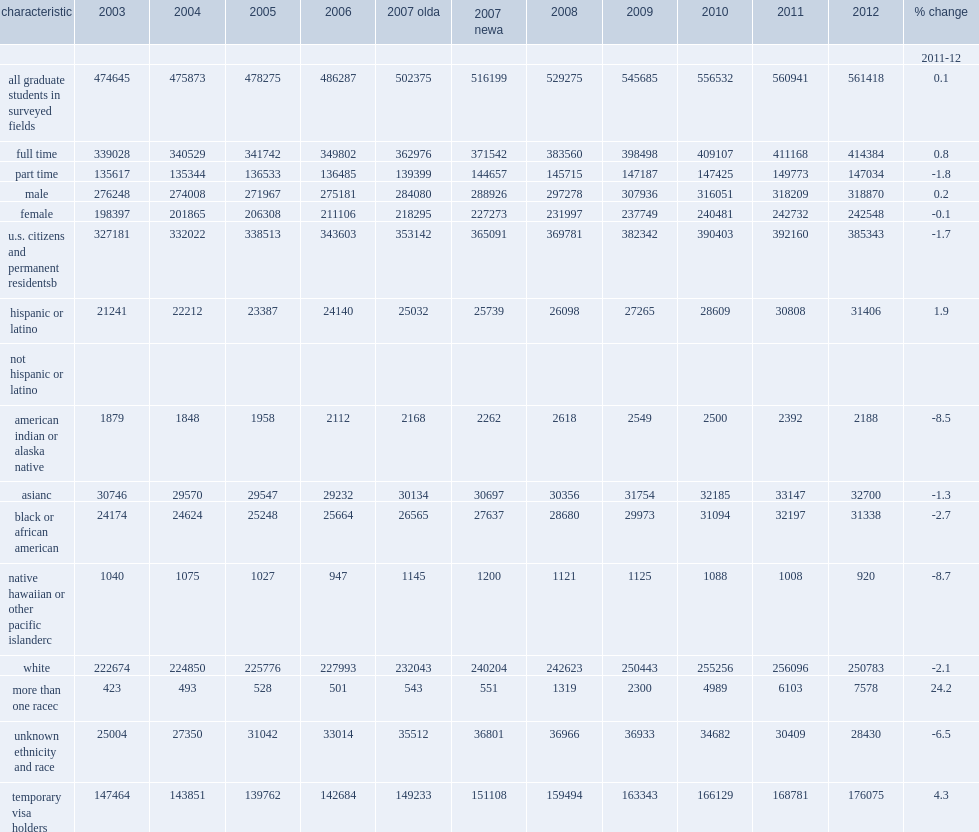What was the number of u.s. citizens and permanent residents enrolled in science and engineering (s&e) graduate programs declined to in 2012? 385343.0. How many percent of dropping from 2011 in enrollment of foreign s&e graduate students on temporary visas? 1.7. How many percent of increase in enrollment of foreign s&e graduate students on temporary visas? 4.3. An increase in enrollment of foreign s&e graduate students on temporary visas, how many students did it rise to? 176075.0. How many percent did enrollment of part-time s&e graduate students decline by? 1.8. How many students did enrollment of part-time s&e graduate students decline to? 147034.0. How many percent of full-time enrollment grew by in 2012? 0.8. How many students did full-time enrollment grow to in 2012? 414384.0. How many percent did full-time students make up of the s&e graduate student population? 0.738102. How many percent did women make up of the s&e graduate enrollment in 2012? 0.432027. Would you be able to parse every entry in this table? {'header': ['characteristic', '2003', '2004', '2005', '2006', '2007 olda', '2007 newa', '2008', '2009', '2010', '2011', '2012', '% change'], 'rows': [['', '', '', '', '', '', '', '', '', '', '', '', '2011-12'], ['all graduate students in surveyed fields', '474645', '475873', '478275', '486287', '502375', '516199', '529275', '545685', '556532', '560941', '561418', '0.1'], ['full time', '339028', '340529', '341742', '349802', '362976', '371542', '383560', '398498', '409107', '411168', '414384', '0.8'], ['part time', '135617', '135344', '136533', '136485', '139399', '144657', '145715', '147187', '147425', '149773', '147034', '-1.8'], ['male', '276248', '274008', '271967', '275181', '284080', '288926', '297278', '307936', '316051', '318209', '318870', '0.2'], ['female', '198397', '201865', '206308', '211106', '218295', '227273', '231997', '237749', '240481', '242732', '242548', '-0.1'], ['u.s. citizens and permanent residentsb', '327181', '332022', '338513', '343603', '353142', '365091', '369781', '382342', '390403', '392160', '385343', '-1.7'], ['hispanic or latino', '21241', '22212', '23387', '24140', '25032', '25739', '26098', '27265', '28609', '30808', '31406', '1.9'], ['not hispanic or latino', '', '', '', '', '', '', '', '', '', '', '', ''], ['american indian or alaska native', '1879', '1848', '1958', '2112', '2168', '2262', '2618', '2549', '2500', '2392', '2188', '-8.5'], ['asianc', '30746', '29570', '29547', '29232', '30134', '30697', '30356', '31754', '32185', '33147', '32700', '-1.3'], ['black or african american', '24174', '24624', '25248', '25664', '26565', '27637', '28680', '29973', '31094', '32197', '31338', '-2.7'], ['native hawaiian or other pacific islanderc', '1040', '1075', '1027', '947', '1145', '1200', '1121', '1125', '1088', '1008', '920', '-8.7'], ['white', '222674', '224850', '225776', '227993', '232043', '240204', '242623', '250443', '255256', '256096', '250783', '-2.1'], ['more than one racec', '423', '493', '528', '501', '543', '551', '1319', '2300', '4989', '6103', '7578', '24.2'], ['unknown ethnicity and race', '25004', '27350', '31042', '33014', '35512', '36801', '36966', '36933', '34682', '30409', '28430', '-6.5'], ['temporary visa holders', '147464', '143851', '139762', '142684', '149233', '151108', '159494', '163343', '166129', '168781', '176075', '4.3']]} 